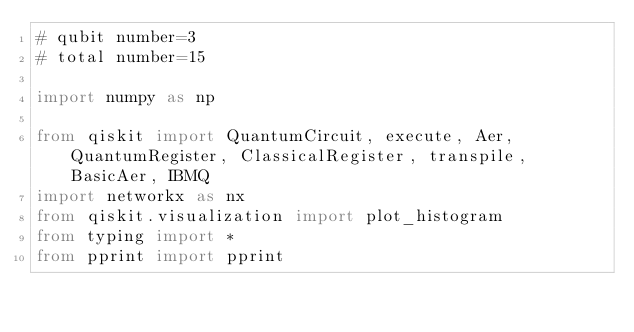<code> <loc_0><loc_0><loc_500><loc_500><_Python_># qubit number=3
# total number=15

import numpy as np

from qiskit import QuantumCircuit, execute, Aer, QuantumRegister, ClassicalRegister, transpile, BasicAer, IBMQ
import networkx as nx
from qiskit.visualization import plot_histogram
from typing import *
from pprint import pprint</code> 